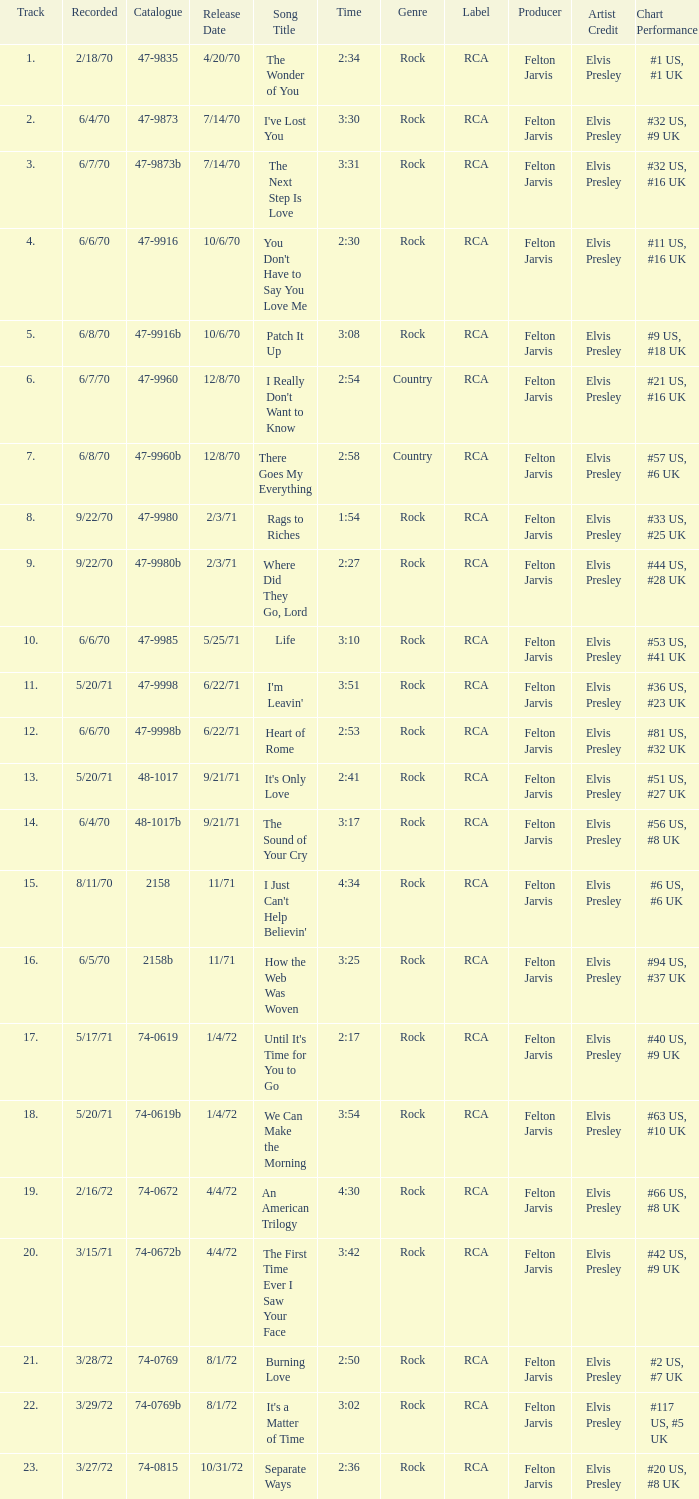Which song was released 12/8/70 with a time of 2:54? I Really Don't Want to Know. 